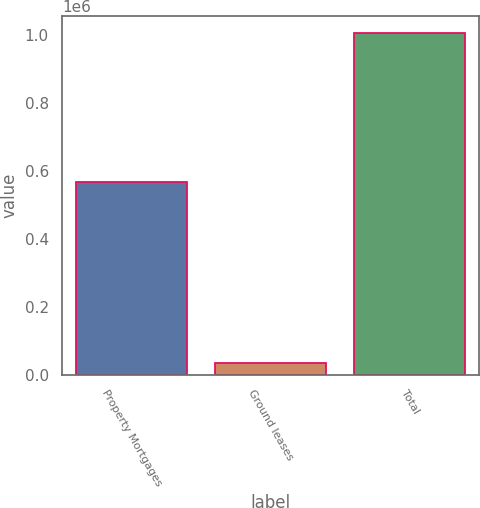Convert chart. <chart><loc_0><loc_0><loc_500><loc_500><bar_chart><fcel>Property Mortgages<fcel>Ground leases<fcel>Total<nl><fcel>568649<fcel>33429<fcel>1.0066e+06<nl></chart> 